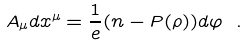<formula> <loc_0><loc_0><loc_500><loc_500>A _ { \mu } d x ^ { \mu } = \frac { 1 } { e } ( n - P ( \rho ) ) d \varphi \ .</formula> 